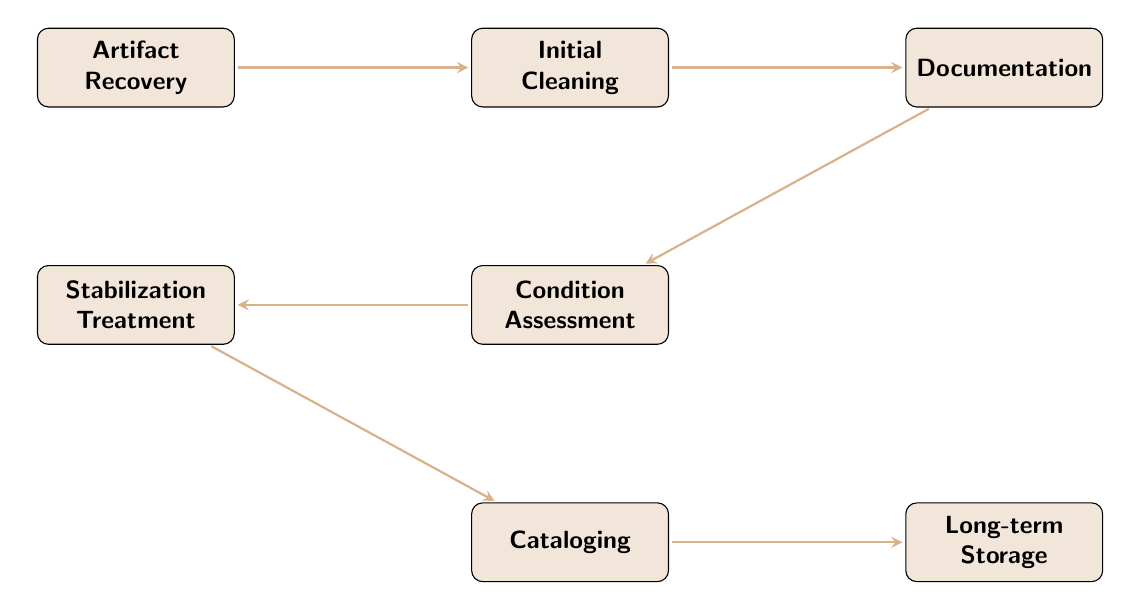What is the first step in the artifact preservation workflow? The first step is represented by the node "Artifact Recovery," which indicates that artifacts are collected from the excavation site. This node is the starting point of the flow chart, leading to subsequent steps.
Answer: Artifact Recovery How many nodes are in the flow chart? By counting the distinct stages represented in the diagram, we find a total of seven nodes, each representing a different step in the artifact preservation workflow.
Answer: 7 What follows after "Initial Cleaning"? The node that follows "Initial Cleaning" is "Documentation." This shows the progression from cleaning to documenting the artifacts with photographs, sketches, and notes.
Answer: Documentation Which step directly leads to "Condition Assessment"? The step that directly leads to "Condition Assessment" is "Documentation." The flow indicates that after artifacts are documented, the next phase is to assess their condition for preservation.
Answer: Documentation What is the last step in the artifact preservation workflow? The final step in the workflow is "Long-term Storage," indicating that after all preceding steps, artifacts are stored in climate-controlled environments to ensure their preservation.
Answer: Long-term Storage Which two steps have a direct relationship? "Initial Cleaning" and "Documentation" have a direct relationship, as "Initial Cleaning" leads directly to "Documentation" in the flow of the workflow.
Answer: Initial Cleaning and Documentation What is the purpose of "Stabilization Treatment"? "Stabilization Treatment" refers to the application of necessary chemical or physical treatments to stabilize the artifacts, ensuring their preservation before cataloging.
Answer: Stabilization Treatment What is the relationship between "Condition Assessment" and "Cataloging"? The relationship is that "Condition Assessment" leads to "Cataloging." After assessing the condition of artifacts, the next step is to catalog them for future reference.
Answer: Condition Assessment leads to Cataloging 